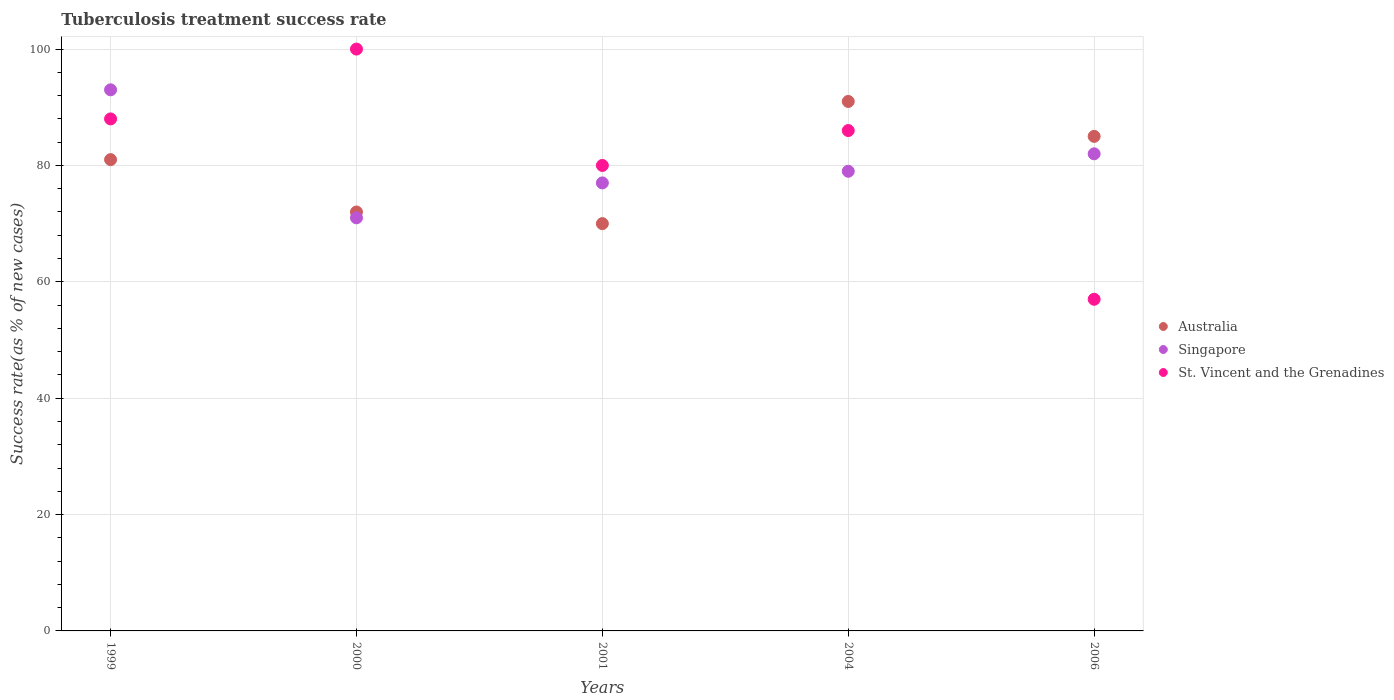What is the tuberculosis treatment success rate in St. Vincent and the Grenadines in 2000?
Ensure brevity in your answer.  100. Across all years, what is the maximum tuberculosis treatment success rate in Australia?
Offer a very short reply. 91. In which year was the tuberculosis treatment success rate in Singapore maximum?
Provide a succinct answer. 1999. In which year was the tuberculosis treatment success rate in St. Vincent and the Grenadines minimum?
Your answer should be compact. 2006. What is the total tuberculosis treatment success rate in Singapore in the graph?
Offer a terse response. 402. What is the average tuberculosis treatment success rate in St. Vincent and the Grenadines per year?
Give a very brief answer. 82.2. In the year 2004, what is the difference between the tuberculosis treatment success rate in St. Vincent and the Grenadines and tuberculosis treatment success rate in Australia?
Keep it short and to the point. -5. What is the ratio of the tuberculosis treatment success rate in Singapore in 1999 to that in 2006?
Offer a very short reply. 1.13. Is the difference between the tuberculosis treatment success rate in St. Vincent and the Grenadines in 1999 and 2006 greater than the difference between the tuberculosis treatment success rate in Australia in 1999 and 2006?
Give a very brief answer. Yes. What is the difference between the highest and the second highest tuberculosis treatment success rate in Australia?
Ensure brevity in your answer.  6. What is the difference between the highest and the lowest tuberculosis treatment success rate in Singapore?
Offer a terse response. 22. Is the sum of the tuberculosis treatment success rate in Australia in 1999 and 2001 greater than the maximum tuberculosis treatment success rate in St. Vincent and the Grenadines across all years?
Your answer should be very brief. Yes. Does the tuberculosis treatment success rate in Singapore monotonically increase over the years?
Keep it short and to the point. No. Is the tuberculosis treatment success rate in Singapore strictly less than the tuberculosis treatment success rate in St. Vincent and the Grenadines over the years?
Your answer should be very brief. No. How many dotlines are there?
Provide a short and direct response. 3. Are the values on the major ticks of Y-axis written in scientific E-notation?
Provide a succinct answer. No. Does the graph contain grids?
Offer a terse response. Yes. Where does the legend appear in the graph?
Keep it short and to the point. Center right. How many legend labels are there?
Your response must be concise. 3. How are the legend labels stacked?
Provide a short and direct response. Vertical. What is the title of the graph?
Your answer should be very brief. Tuberculosis treatment success rate. What is the label or title of the X-axis?
Provide a succinct answer. Years. What is the label or title of the Y-axis?
Ensure brevity in your answer.  Success rate(as % of new cases). What is the Success rate(as % of new cases) of Australia in 1999?
Ensure brevity in your answer.  81. What is the Success rate(as % of new cases) of Singapore in 1999?
Provide a short and direct response. 93. What is the Success rate(as % of new cases) of Singapore in 2000?
Your response must be concise. 71. What is the Success rate(as % of new cases) of Australia in 2004?
Keep it short and to the point. 91. What is the Success rate(as % of new cases) in Singapore in 2004?
Provide a succinct answer. 79. What is the Success rate(as % of new cases) of St. Vincent and the Grenadines in 2004?
Your response must be concise. 86. What is the Success rate(as % of new cases) in Singapore in 2006?
Your answer should be compact. 82. Across all years, what is the maximum Success rate(as % of new cases) of Australia?
Give a very brief answer. 91. Across all years, what is the maximum Success rate(as % of new cases) in Singapore?
Your response must be concise. 93. Across all years, what is the maximum Success rate(as % of new cases) of St. Vincent and the Grenadines?
Provide a short and direct response. 100. Across all years, what is the minimum Success rate(as % of new cases) of Singapore?
Offer a very short reply. 71. Across all years, what is the minimum Success rate(as % of new cases) of St. Vincent and the Grenadines?
Your answer should be very brief. 57. What is the total Success rate(as % of new cases) of Australia in the graph?
Your answer should be very brief. 399. What is the total Success rate(as % of new cases) of Singapore in the graph?
Offer a very short reply. 402. What is the total Success rate(as % of new cases) of St. Vincent and the Grenadines in the graph?
Your answer should be compact. 411. What is the difference between the Success rate(as % of new cases) of Australia in 1999 and that in 2000?
Offer a very short reply. 9. What is the difference between the Success rate(as % of new cases) in Singapore in 1999 and that in 2000?
Give a very brief answer. 22. What is the difference between the Success rate(as % of new cases) in St. Vincent and the Grenadines in 1999 and that in 2000?
Provide a short and direct response. -12. What is the difference between the Success rate(as % of new cases) in Australia in 1999 and that in 2001?
Your answer should be compact. 11. What is the difference between the Success rate(as % of new cases) of Australia in 1999 and that in 2006?
Keep it short and to the point. -4. What is the difference between the Success rate(as % of new cases) in St. Vincent and the Grenadines in 1999 and that in 2006?
Your answer should be compact. 31. What is the difference between the Success rate(as % of new cases) in Australia in 2000 and that in 2001?
Keep it short and to the point. 2. What is the difference between the Success rate(as % of new cases) of Australia in 2000 and that in 2004?
Offer a terse response. -19. What is the difference between the Success rate(as % of new cases) of Singapore in 2000 and that in 2004?
Offer a terse response. -8. What is the difference between the Success rate(as % of new cases) of St. Vincent and the Grenadines in 2000 and that in 2004?
Your answer should be compact. 14. What is the difference between the Success rate(as % of new cases) of Singapore in 2000 and that in 2006?
Keep it short and to the point. -11. What is the difference between the Success rate(as % of new cases) in St. Vincent and the Grenadines in 2000 and that in 2006?
Your answer should be very brief. 43. What is the difference between the Success rate(as % of new cases) of Singapore in 2001 and that in 2004?
Offer a terse response. -2. What is the difference between the Success rate(as % of new cases) of St. Vincent and the Grenadines in 2001 and that in 2006?
Offer a terse response. 23. What is the difference between the Success rate(as % of new cases) of St. Vincent and the Grenadines in 2004 and that in 2006?
Your response must be concise. 29. What is the difference between the Success rate(as % of new cases) of Australia in 1999 and the Success rate(as % of new cases) of Singapore in 2000?
Make the answer very short. 10. What is the difference between the Success rate(as % of new cases) of Australia in 1999 and the Success rate(as % of new cases) of St. Vincent and the Grenadines in 2000?
Provide a short and direct response. -19. What is the difference between the Success rate(as % of new cases) of Australia in 1999 and the Success rate(as % of new cases) of St. Vincent and the Grenadines in 2001?
Give a very brief answer. 1. What is the difference between the Success rate(as % of new cases) of Australia in 1999 and the Success rate(as % of new cases) of Singapore in 2004?
Offer a terse response. 2. What is the difference between the Success rate(as % of new cases) of Singapore in 1999 and the Success rate(as % of new cases) of St. Vincent and the Grenadines in 2006?
Provide a short and direct response. 36. What is the difference between the Success rate(as % of new cases) in Australia in 2000 and the Success rate(as % of new cases) in Singapore in 2001?
Make the answer very short. -5. What is the difference between the Success rate(as % of new cases) of Australia in 2000 and the Success rate(as % of new cases) of St. Vincent and the Grenadines in 2001?
Make the answer very short. -8. What is the difference between the Success rate(as % of new cases) in Singapore in 2000 and the Success rate(as % of new cases) in St. Vincent and the Grenadines in 2004?
Provide a succinct answer. -15. What is the difference between the Success rate(as % of new cases) in Australia in 2000 and the Success rate(as % of new cases) in Singapore in 2006?
Give a very brief answer. -10. What is the difference between the Success rate(as % of new cases) in Australia in 2000 and the Success rate(as % of new cases) in St. Vincent and the Grenadines in 2006?
Give a very brief answer. 15. What is the difference between the Success rate(as % of new cases) in Australia in 2001 and the Success rate(as % of new cases) in St. Vincent and the Grenadines in 2004?
Give a very brief answer. -16. What is the difference between the Success rate(as % of new cases) in Australia in 2001 and the Success rate(as % of new cases) in St. Vincent and the Grenadines in 2006?
Offer a terse response. 13. What is the difference between the Success rate(as % of new cases) in Australia in 2004 and the Success rate(as % of new cases) in Singapore in 2006?
Provide a short and direct response. 9. What is the difference between the Success rate(as % of new cases) in Australia in 2004 and the Success rate(as % of new cases) in St. Vincent and the Grenadines in 2006?
Your answer should be very brief. 34. What is the difference between the Success rate(as % of new cases) in Singapore in 2004 and the Success rate(as % of new cases) in St. Vincent and the Grenadines in 2006?
Your answer should be compact. 22. What is the average Success rate(as % of new cases) of Australia per year?
Make the answer very short. 79.8. What is the average Success rate(as % of new cases) of Singapore per year?
Provide a short and direct response. 80.4. What is the average Success rate(as % of new cases) of St. Vincent and the Grenadines per year?
Make the answer very short. 82.2. In the year 1999, what is the difference between the Success rate(as % of new cases) of Australia and Success rate(as % of new cases) of Singapore?
Keep it short and to the point. -12. In the year 2000, what is the difference between the Success rate(as % of new cases) in Australia and Success rate(as % of new cases) in Singapore?
Keep it short and to the point. 1. In the year 2004, what is the difference between the Success rate(as % of new cases) in Australia and Success rate(as % of new cases) in St. Vincent and the Grenadines?
Provide a short and direct response. 5. In the year 2006, what is the difference between the Success rate(as % of new cases) of Singapore and Success rate(as % of new cases) of St. Vincent and the Grenadines?
Keep it short and to the point. 25. What is the ratio of the Success rate(as % of new cases) in Singapore in 1999 to that in 2000?
Keep it short and to the point. 1.31. What is the ratio of the Success rate(as % of new cases) of St. Vincent and the Grenadines in 1999 to that in 2000?
Provide a succinct answer. 0.88. What is the ratio of the Success rate(as % of new cases) in Australia in 1999 to that in 2001?
Your answer should be compact. 1.16. What is the ratio of the Success rate(as % of new cases) in Singapore in 1999 to that in 2001?
Make the answer very short. 1.21. What is the ratio of the Success rate(as % of new cases) in St. Vincent and the Grenadines in 1999 to that in 2001?
Your response must be concise. 1.1. What is the ratio of the Success rate(as % of new cases) in Australia in 1999 to that in 2004?
Make the answer very short. 0.89. What is the ratio of the Success rate(as % of new cases) of Singapore in 1999 to that in 2004?
Provide a short and direct response. 1.18. What is the ratio of the Success rate(as % of new cases) in St. Vincent and the Grenadines in 1999 to that in 2004?
Ensure brevity in your answer.  1.02. What is the ratio of the Success rate(as % of new cases) of Australia in 1999 to that in 2006?
Provide a short and direct response. 0.95. What is the ratio of the Success rate(as % of new cases) of Singapore in 1999 to that in 2006?
Your response must be concise. 1.13. What is the ratio of the Success rate(as % of new cases) in St. Vincent and the Grenadines in 1999 to that in 2006?
Offer a very short reply. 1.54. What is the ratio of the Success rate(as % of new cases) in Australia in 2000 to that in 2001?
Your response must be concise. 1.03. What is the ratio of the Success rate(as % of new cases) in Singapore in 2000 to that in 2001?
Ensure brevity in your answer.  0.92. What is the ratio of the Success rate(as % of new cases) of St. Vincent and the Grenadines in 2000 to that in 2001?
Make the answer very short. 1.25. What is the ratio of the Success rate(as % of new cases) of Australia in 2000 to that in 2004?
Offer a terse response. 0.79. What is the ratio of the Success rate(as % of new cases) of Singapore in 2000 to that in 2004?
Keep it short and to the point. 0.9. What is the ratio of the Success rate(as % of new cases) in St. Vincent and the Grenadines in 2000 to that in 2004?
Offer a very short reply. 1.16. What is the ratio of the Success rate(as % of new cases) of Australia in 2000 to that in 2006?
Keep it short and to the point. 0.85. What is the ratio of the Success rate(as % of new cases) of Singapore in 2000 to that in 2006?
Provide a succinct answer. 0.87. What is the ratio of the Success rate(as % of new cases) in St. Vincent and the Grenadines in 2000 to that in 2006?
Your response must be concise. 1.75. What is the ratio of the Success rate(as % of new cases) of Australia in 2001 to that in 2004?
Ensure brevity in your answer.  0.77. What is the ratio of the Success rate(as % of new cases) of Singapore in 2001 to that in 2004?
Your answer should be very brief. 0.97. What is the ratio of the Success rate(as % of new cases) in St. Vincent and the Grenadines in 2001 to that in 2004?
Offer a very short reply. 0.93. What is the ratio of the Success rate(as % of new cases) of Australia in 2001 to that in 2006?
Provide a succinct answer. 0.82. What is the ratio of the Success rate(as % of new cases) of Singapore in 2001 to that in 2006?
Make the answer very short. 0.94. What is the ratio of the Success rate(as % of new cases) in St. Vincent and the Grenadines in 2001 to that in 2006?
Offer a terse response. 1.4. What is the ratio of the Success rate(as % of new cases) of Australia in 2004 to that in 2006?
Your answer should be compact. 1.07. What is the ratio of the Success rate(as % of new cases) in Singapore in 2004 to that in 2006?
Give a very brief answer. 0.96. What is the ratio of the Success rate(as % of new cases) of St. Vincent and the Grenadines in 2004 to that in 2006?
Ensure brevity in your answer.  1.51. What is the difference between the highest and the second highest Success rate(as % of new cases) of Singapore?
Keep it short and to the point. 11. What is the difference between the highest and the second highest Success rate(as % of new cases) in St. Vincent and the Grenadines?
Offer a terse response. 12. What is the difference between the highest and the lowest Success rate(as % of new cases) in Australia?
Your answer should be compact. 21. What is the difference between the highest and the lowest Success rate(as % of new cases) in Singapore?
Offer a terse response. 22. What is the difference between the highest and the lowest Success rate(as % of new cases) in St. Vincent and the Grenadines?
Provide a short and direct response. 43. 